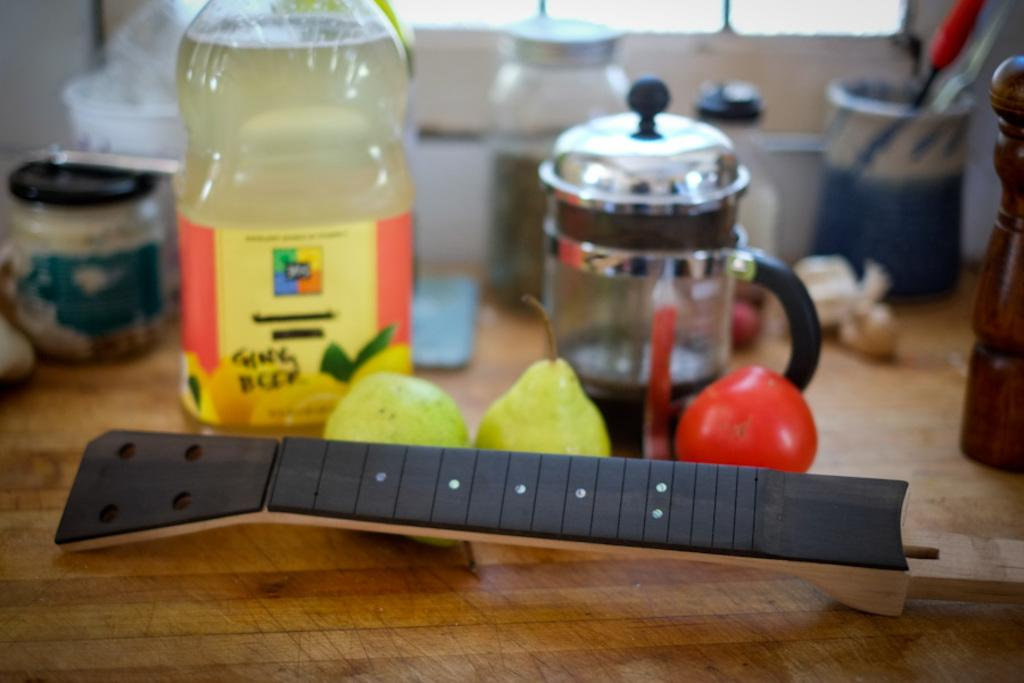What objects are present on the table in the image? There are bottles and fruits on the table in the image. What type of fruits can be seen in the image? The image contains fruits, but the specific types cannot be determined from the provided facts. What is the purpose of the bottles in the image? The purpose of the bottles in the image cannot be determined from the provided facts. How does the hammer stretch the fruits in the image? There is no hammer present in the image, and therefore no such action can be observed. 